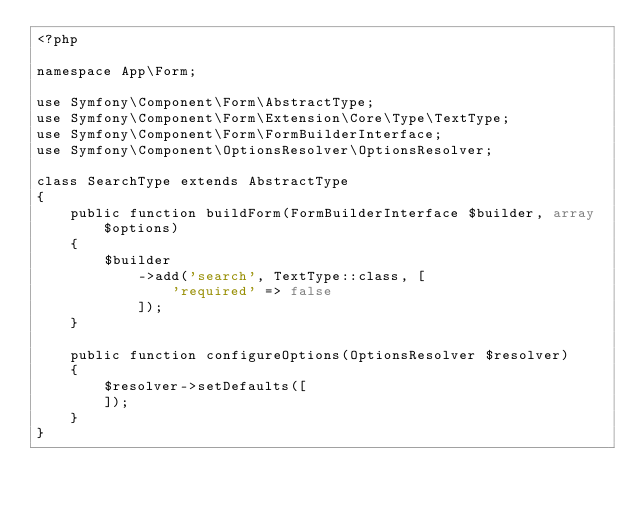Convert code to text. <code><loc_0><loc_0><loc_500><loc_500><_PHP_><?php

namespace App\Form;

use Symfony\Component\Form\AbstractType;
use Symfony\Component\Form\Extension\Core\Type\TextType;
use Symfony\Component\Form\FormBuilderInterface;
use Symfony\Component\OptionsResolver\OptionsResolver;

class SearchType extends AbstractType
{
    public function buildForm(FormBuilderInterface $builder, array $options)
    {
        $builder
            ->add('search', TextType::class, [
                'required' => false
            ]);
    }

    public function configureOptions(OptionsResolver $resolver)
    {
        $resolver->setDefaults([
        ]);
    }
}
</code> 